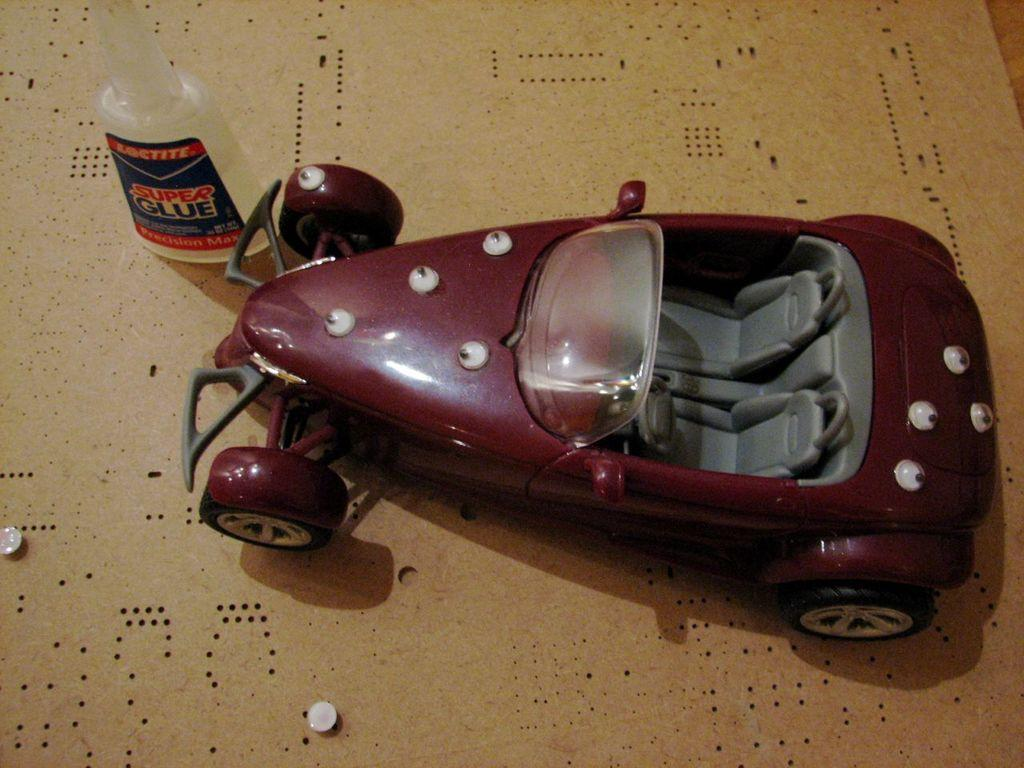What type of toy is present in the image? There is a toy car in the image. Can you describe the object on the left side of the image? There is a glue bottle on the left side of the image. What is located at the bottom of the image? There is a cardboard sheet at the bottom of the image. What scent can be detected from the toy car in the image? There is no mention of a scent in the image, and the toy car is not described as having a scent. 